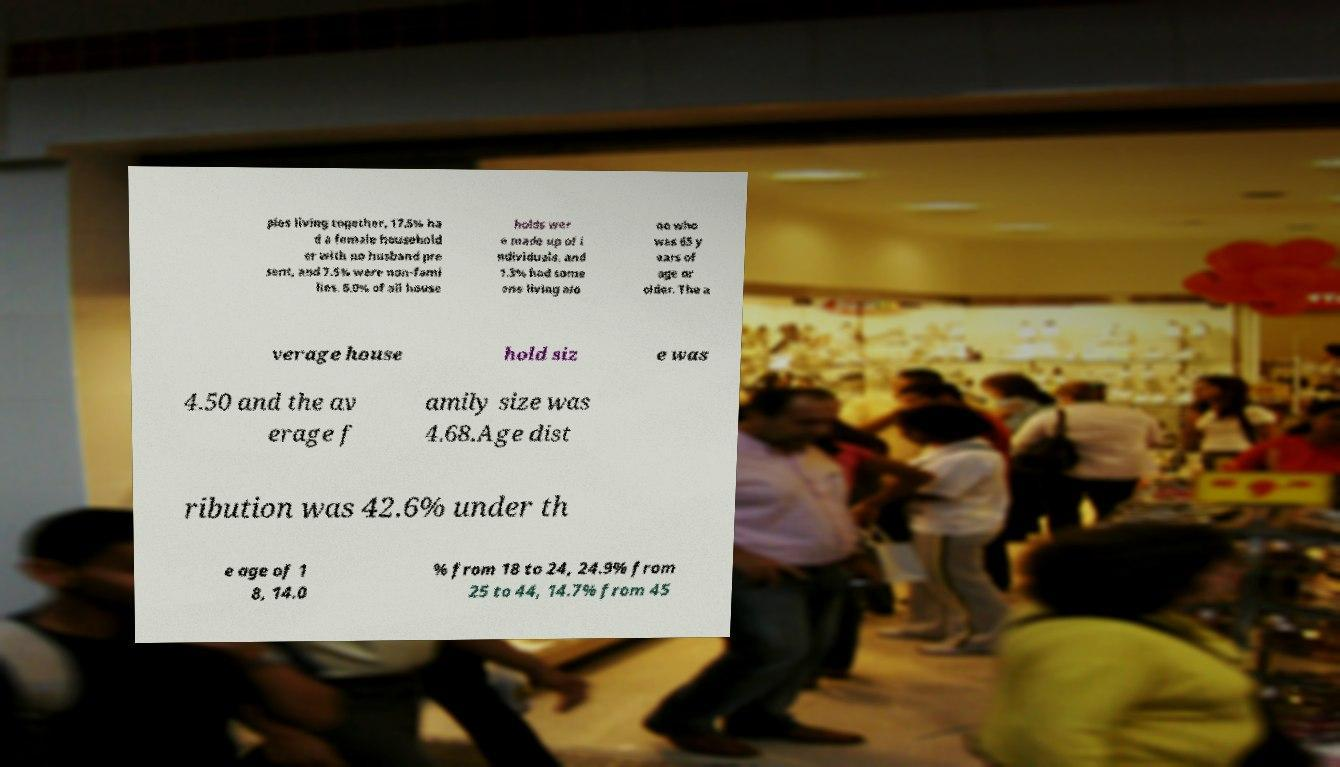For documentation purposes, I need the text within this image transcribed. Could you provide that? ples living together, 17.5% ha d a female household er with no husband pre sent, and 7.5% were non-fami lies. 5.0% of all house holds wer e made up of i ndividuals, and 1.3% had some one living alo ne who was 65 y ears of age or older. The a verage house hold siz e was 4.50 and the av erage f amily size was 4.68.Age dist ribution was 42.6% under th e age of 1 8, 14.0 % from 18 to 24, 24.9% from 25 to 44, 14.7% from 45 